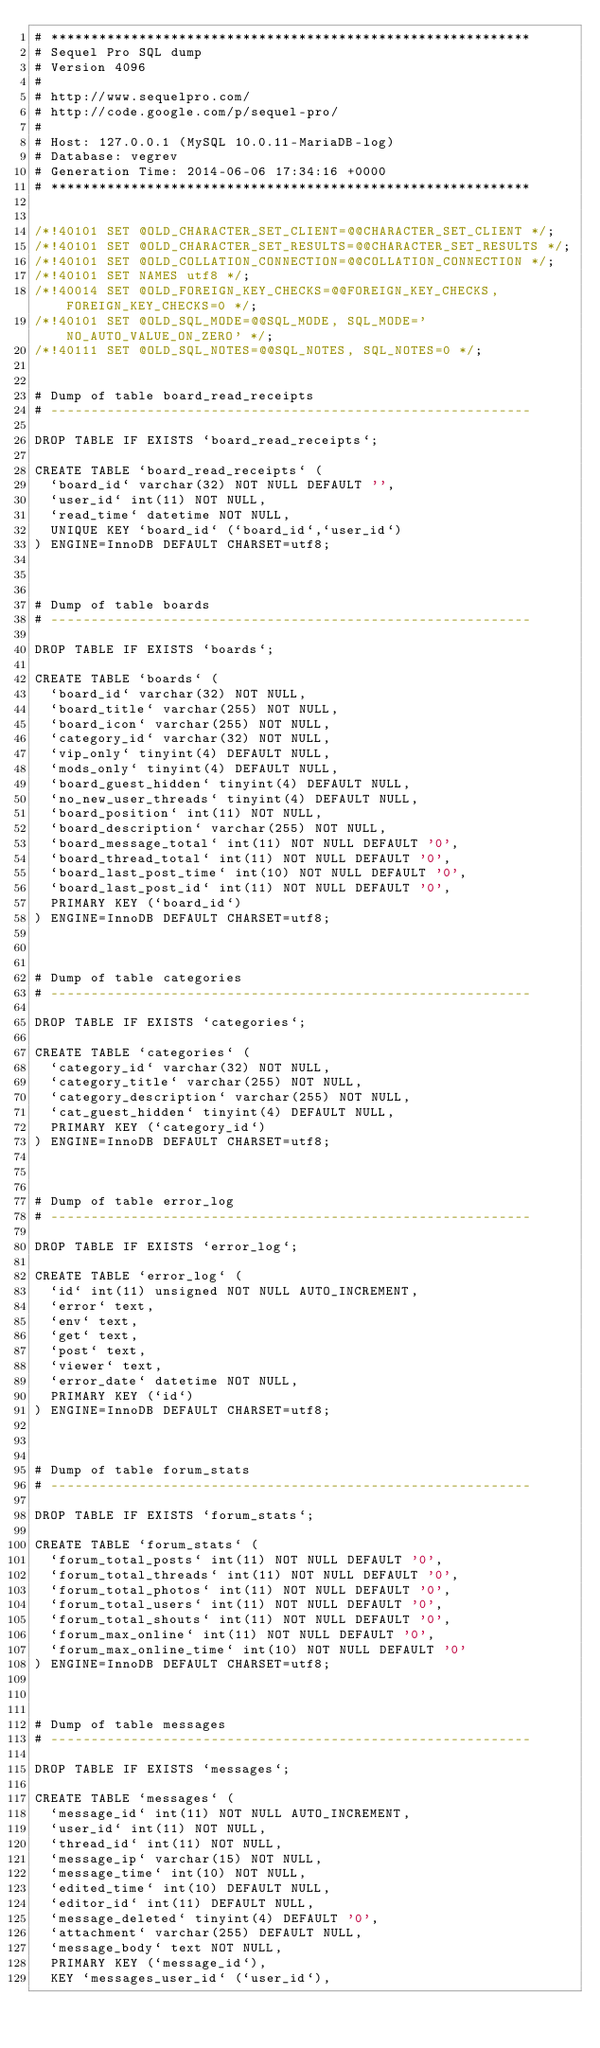Convert code to text. <code><loc_0><loc_0><loc_500><loc_500><_SQL_># ************************************************************
# Sequel Pro SQL dump
# Version 4096
#
# http://www.sequelpro.com/
# http://code.google.com/p/sequel-pro/
#
# Host: 127.0.0.1 (MySQL 10.0.11-MariaDB-log)
# Database: vegrev
# Generation Time: 2014-06-06 17:34:16 +0000
# ************************************************************


/*!40101 SET @OLD_CHARACTER_SET_CLIENT=@@CHARACTER_SET_CLIENT */;
/*!40101 SET @OLD_CHARACTER_SET_RESULTS=@@CHARACTER_SET_RESULTS */;
/*!40101 SET @OLD_COLLATION_CONNECTION=@@COLLATION_CONNECTION */;
/*!40101 SET NAMES utf8 */;
/*!40014 SET @OLD_FOREIGN_KEY_CHECKS=@@FOREIGN_KEY_CHECKS, FOREIGN_KEY_CHECKS=0 */;
/*!40101 SET @OLD_SQL_MODE=@@SQL_MODE, SQL_MODE='NO_AUTO_VALUE_ON_ZERO' */;
/*!40111 SET @OLD_SQL_NOTES=@@SQL_NOTES, SQL_NOTES=0 */;


# Dump of table board_read_receipts
# ------------------------------------------------------------

DROP TABLE IF EXISTS `board_read_receipts`;

CREATE TABLE `board_read_receipts` (
  `board_id` varchar(32) NOT NULL DEFAULT '',
  `user_id` int(11) NOT NULL,
  `read_time` datetime NOT NULL,
  UNIQUE KEY `board_id` (`board_id`,`user_id`)
) ENGINE=InnoDB DEFAULT CHARSET=utf8;



# Dump of table boards
# ------------------------------------------------------------

DROP TABLE IF EXISTS `boards`;

CREATE TABLE `boards` (
  `board_id` varchar(32) NOT NULL,
  `board_title` varchar(255) NOT NULL,
  `board_icon` varchar(255) NOT NULL,
  `category_id` varchar(32) NOT NULL,
  `vip_only` tinyint(4) DEFAULT NULL,
  `mods_only` tinyint(4) DEFAULT NULL,
  `board_guest_hidden` tinyint(4) DEFAULT NULL,
  `no_new_user_threads` tinyint(4) DEFAULT NULL,
  `board_position` int(11) NOT NULL,
  `board_description` varchar(255) NOT NULL,
  `board_message_total` int(11) NOT NULL DEFAULT '0',
  `board_thread_total` int(11) NOT NULL DEFAULT '0',
  `board_last_post_time` int(10) NOT NULL DEFAULT '0',
  `board_last_post_id` int(11) NOT NULL DEFAULT '0',
  PRIMARY KEY (`board_id`)
) ENGINE=InnoDB DEFAULT CHARSET=utf8;



# Dump of table categories
# ------------------------------------------------------------

DROP TABLE IF EXISTS `categories`;

CREATE TABLE `categories` (
  `category_id` varchar(32) NOT NULL,
  `category_title` varchar(255) NOT NULL,
  `category_description` varchar(255) NOT NULL,
  `cat_guest_hidden` tinyint(4) DEFAULT NULL,
  PRIMARY KEY (`category_id`)
) ENGINE=InnoDB DEFAULT CHARSET=utf8;



# Dump of table error_log
# ------------------------------------------------------------

DROP TABLE IF EXISTS `error_log`;

CREATE TABLE `error_log` (
  `id` int(11) unsigned NOT NULL AUTO_INCREMENT,
  `error` text,
  `env` text,
  `get` text,
  `post` text,
  `viewer` text,
  `error_date` datetime NOT NULL,
  PRIMARY KEY (`id`)
) ENGINE=InnoDB DEFAULT CHARSET=utf8;



# Dump of table forum_stats
# ------------------------------------------------------------

DROP TABLE IF EXISTS `forum_stats`;

CREATE TABLE `forum_stats` (
  `forum_total_posts` int(11) NOT NULL DEFAULT '0',
  `forum_total_threads` int(11) NOT NULL DEFAULT '0',
  `forum_total_photos` int(11) NOT NULL DEFAULT '0',
  `forum_total_users` int(11) NOT NULL DEFAULT '0',
  `forum_total_shouts` int(11) NOT NULL DEFAULT '0',
  `forum_max_online` int(11) NOT NULL DEFAULT '0',
  `forum_max_online_time` int(10) NOT NULL DEFAULT '0'
) ENGINE=InnoDB DEFAULT CHARSET=utf8;



# Dump of table messages
# ------------------------------------------------------------

DROP TABLE IF EXISTS `messages`;

CREATE TABLE `messages` (
  `message_id` int(11) NOT NULL AUTO_INCREMENT,
  `user_id` int(11) NOT NULL,
  `thread_id` int(11) NOT NULL,
  `message_ip` varchar(15) NOT NULL,
  `message_time` int(10) NOT NULL,
  `edited_time` int(10) DEFAULT NULL,
  `editor_id` int(11) DEFAULT NULL,
  `message_deleted` tinyint(4) DEFAULT '0',
  `attachment` varchar(255) DEFAULT NULL,
  `message_body` text NOT NULL,
  PRIMARY KEY (`message_id`),
  KEY `messages_user_id` (`user_id`),</code> 